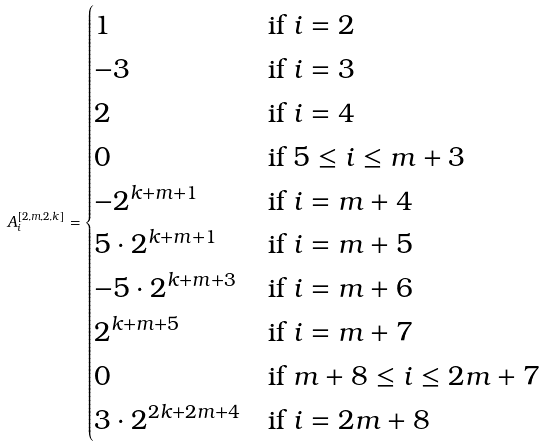Convert formula to latex. <formula><loc_0><loc_0><loc_500><loc_500>A _ { i } ^ { [ 2 , m , 2 , k ] } = \begin{cases} 1 & \text {if } i = 2 \\ - 3 & \text {if } i = 3 \\ 2 & \text {if } i = 4 \\ 0 & \text {if } 5 \leq i \leq m + 3 \\ - 2 ^ { k + m + 1 } & \text {if } i = m + 4 \\ 5 \cdot 2 ^ { k + m + 1 } & \text {if } i = m + 5 \\ - 5 \cdot 2 ^ { k + m + 3 } & \text {if } i = m + 6 \\ 2 ^ { k + m + 5 } & \text {if } i = m + 7 \\ 0 & \text {if } m + 8 \leq i \leq 2 m + 7 \\ 3 \cdot 2 ^ { 2 k + 2 m + 4 } & \text {if } i = 2 m + 8 \end{cases}</formula> 